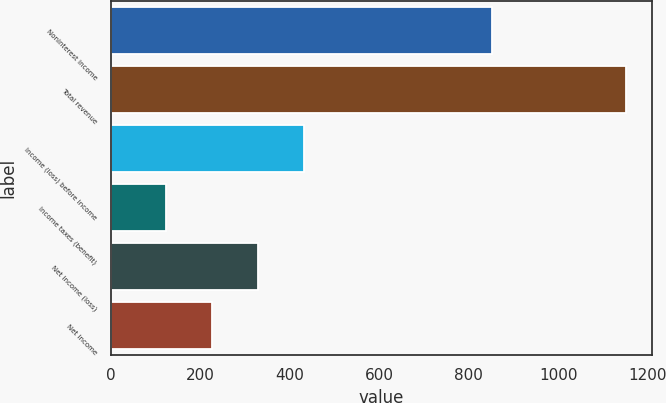Convert chart. <chart><loc_0><loc_0><loc_500><loc_500><bar_chart><fcel>Noninterest income<fcel>Total revenue<fcel>Income (loss) before income<fcel>Income taxes (benefit)<fcel>Net income (loss)<fcel>Net income<nl><fcel>851<fcel>1151<fcel>430.7<fcel>122<fcel>327.8<fcel>224.9<nl></chart> 